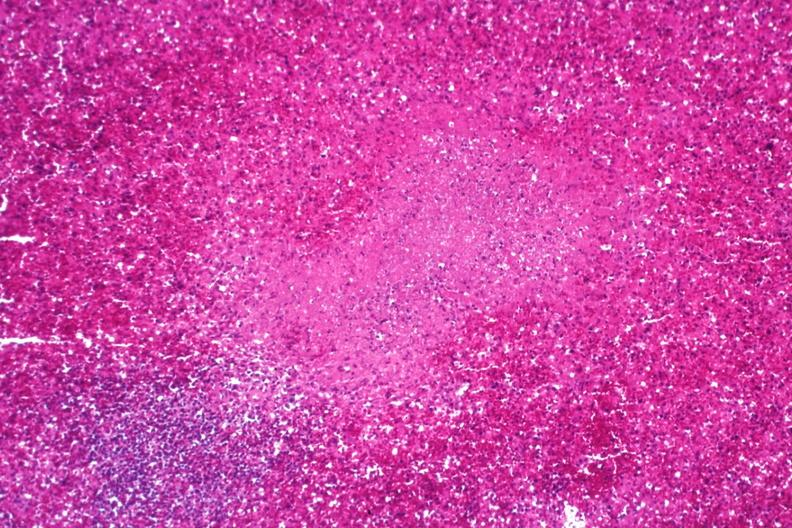s esophagus present?
Answer the question using a single word or phrase. No 